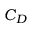Convert formula to latex. <formula><loc_0><loc_0><loc_500><loc_500>C _ { D }</formula> 